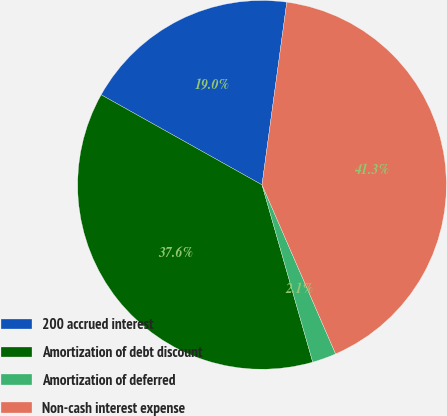Convert chart to OTSL. <chart><loc_0><loc_0><loc_500><loc_500><pie_chart><fcel>200 accrued interest<fcel>Amortization of debt discount<fcel>Amortization of deferred<fcel>Non-cash interest expense<nl><fcel>19.02%<fcel>37.56%<fcel>2.1%<fcel>41.32%<nl></chart> 